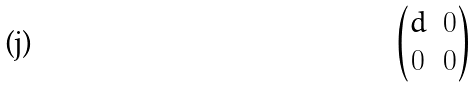Convert formula to latex. <formula><loc_0><loc_0><loc_500><loc_500>\begin{pmatrix} d & 0 \\ 0 & 0 \end{pmatrix}</formula> 